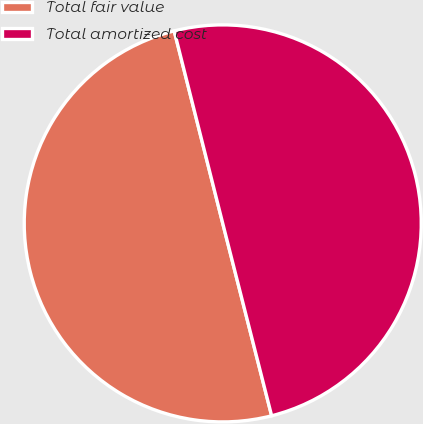Convert chart to OTSL. <chart><loc_0><loc_0><loc_500><loc_500><pie_chart><fcel>Total fair value<fcel>Total amortized cost<nl><fcel>50.03%<fcel>49.97%<nl></chart> 